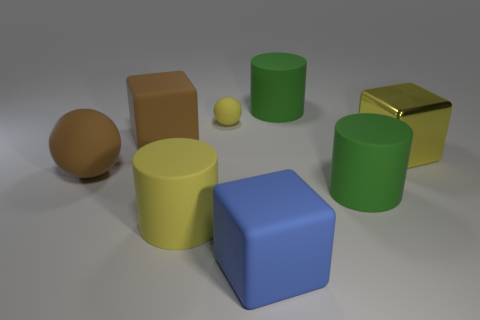Subtract all yellow metallic blocks. How many blocks are left? 2 Subtract all brown spheres. How many spheres are left? 1 Subtract all cubes. How many objects are left? 5 Add 1 blue things. How many objects exist? 9 Subtract all big cylinders. Subtract all big brown balls. How many objects are left? 4 Add 2 yellow rubber balls. How many yellow rubber balls are left? 3 Add 5 large brown objects. How many large brown objects exist? 7 Subtract 0 red cylinders. How many objects are left? 8 Subtract 3 cylinders. How many cylinders are left? 0 Subtract all red cylinders. Subtract all red blocks. How many cylinders are left? 3 